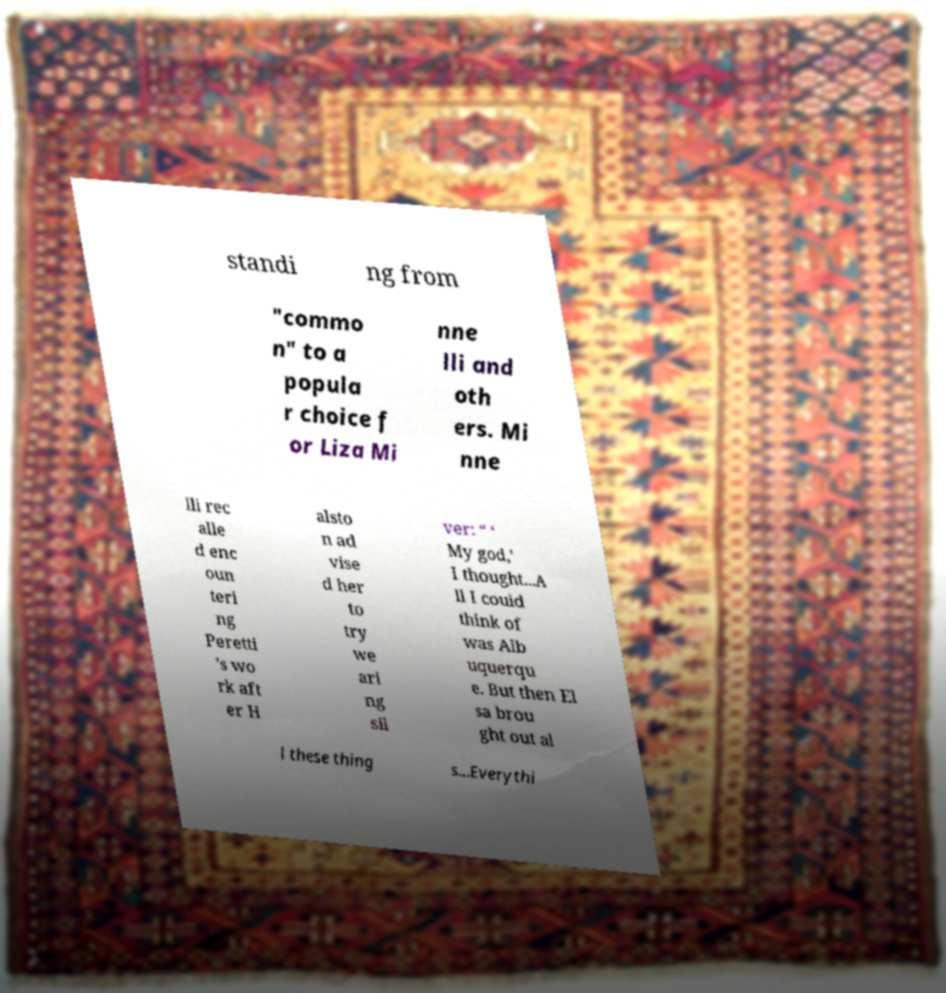What messages or text are displayed in this image? I need them in a readable, typed format. standi ng from "commo n" to a popula r choice f or Liza Mi nne lli and oth ers. Mi nne lli rec alle d enc oun teri ng Peretti ’s wo rk aft er H alsto n ad vise d her to try we ari ng sil ver: “ ‘ My god,’ I thought...A ll I could think of was Alb uquerqu e. But then El sa brou ght out al l these thing s...Everythi 